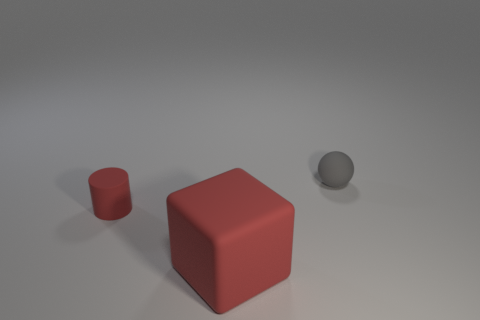Add 3 red matte cylinders. How many objects exist? 6 Subtract all cubes. How many objects are left? 2 Subtract 0 yellow balls. How many objects are left? 3 Subtract all red things. Subtract all spheres. How many objects are left? 0 Add 1 large matte things. How many large matte things are left? 2 Add 3 small red matte cylinders. How many small red matte cylinders exist? 4 